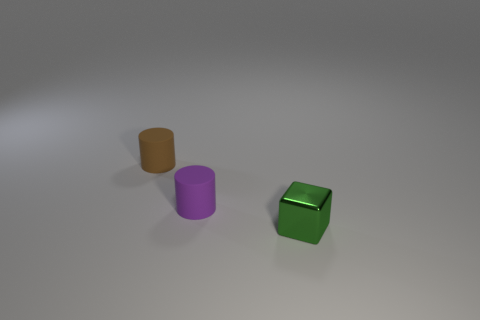There is a green shiny object; are there any small brown rubber cylinders in front of it? Indeed, there is a small brown cylindrical object situated to the left of the green shiny cube, when viewed from this perspective. 